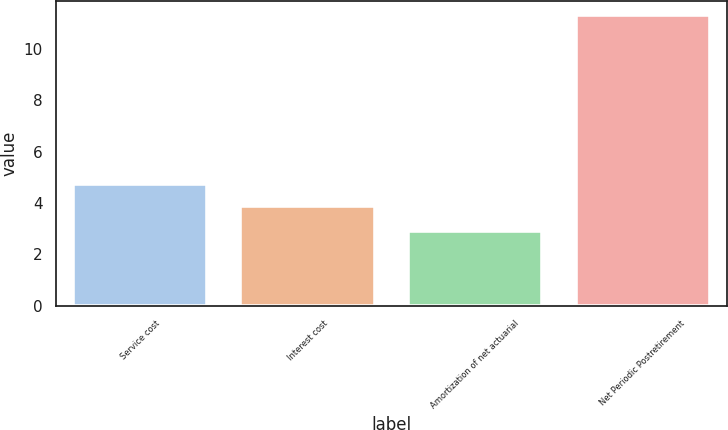Convert chart. <chart><loc_0><loc_0><loc_500><loc_500><bar_chart><fcel>Service cost<fcel>Interest cost<fcel>Amortization of net actuarial<fcel>Net Periodic Postretirement<nl><fcel>4.74<fcel>3.9<fcel>2.9<fcel>11.3<nl></chart> 